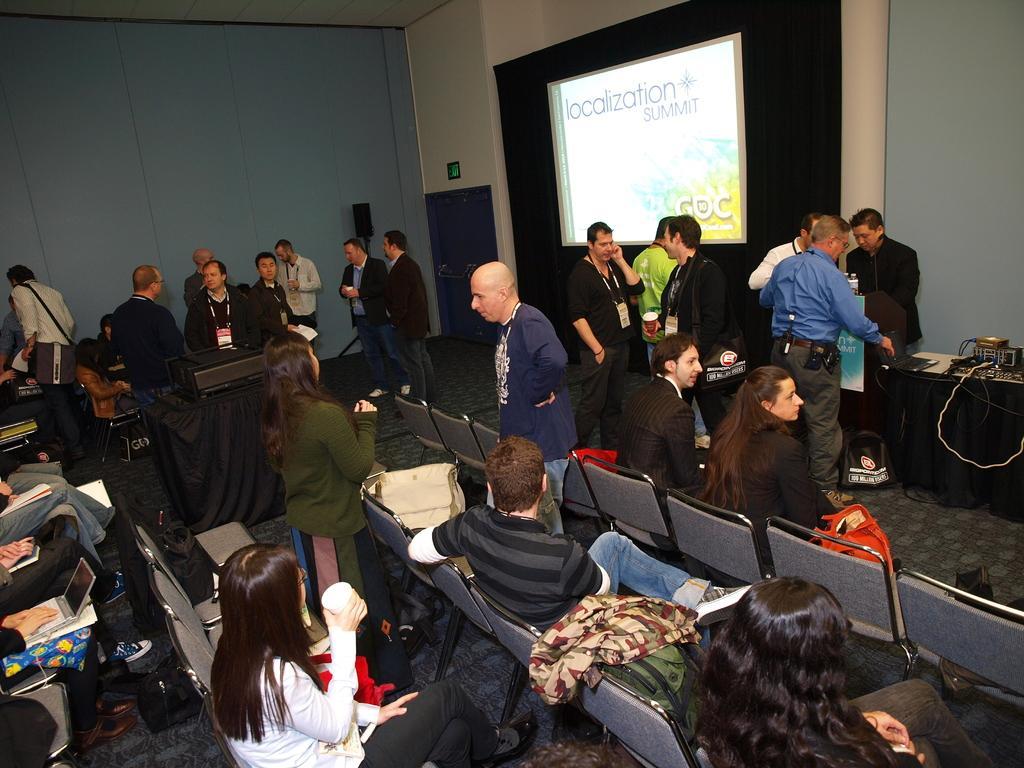Can you describe this image briefly? In this image few persons are sitting on the chairs. Few persons are standing on the floor. Right side there is a table having a laptop and few items are on it. A woman wearing a white shirt is holding a glass in her hand. Left side a person is having a laptop on her lap. Beside two persons are sitting and they are having books on their lap. A person wearing a white shirt is carrying a bag and standing on the floor. There is a table having a projector on it. Bottom of image there is a bag and a cloth are on the chair. Top of image there is a screen attached to the wall. 